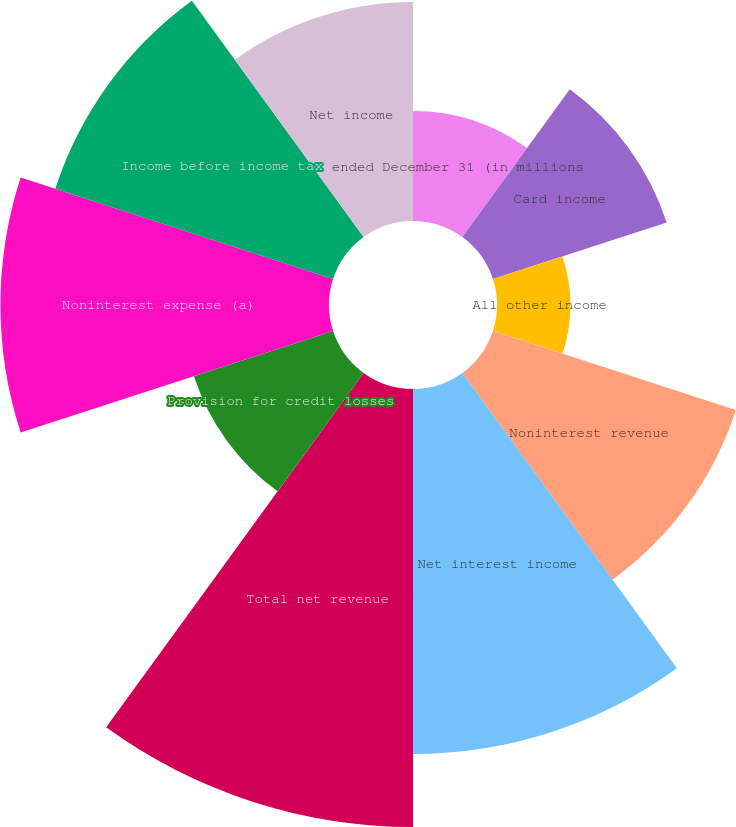<chart> <loc_0><loc_0><loc_500><loc_500><pie_chart><fcel>ended December 31 (in millions<fcel>Card income<fcel>All other income<fcel>Noninterest revenue<fcel>Net interest income<fcel>Total net revenue<fcel>Provision for credit losses<fcel>Noninterest expense (a)<fcel>Income before income tax<fcel>Net income<nl><fcel>4.56%<fcel>7.58%<fcel>3.04%<fcel>10.6%<fcel>15.14%<fcel>18.17%<fcel>6.07%<fcel>13.63%<fcel>12.12%<fcel>9.09%<nl></chart> 